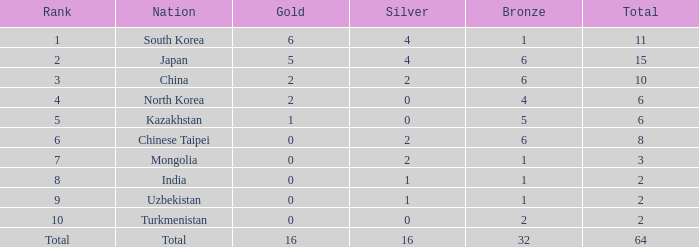What is the sum of gold amounts that are less than 0? 0.0. 